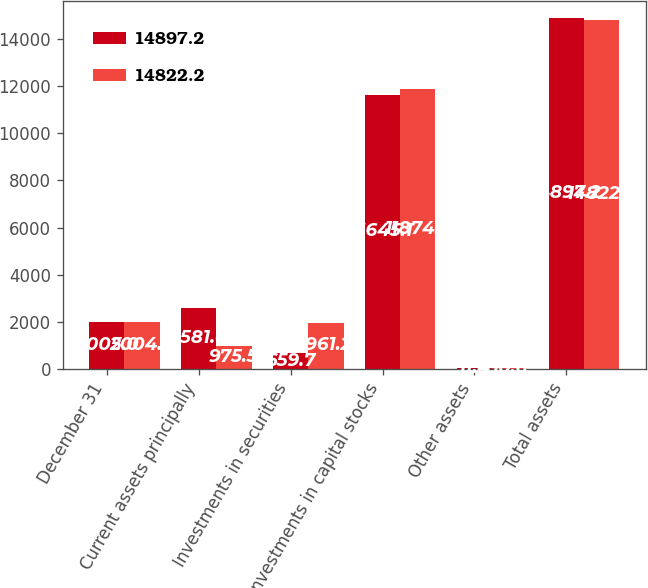Convert chart to OTSL. <chart><loc_0><loc_0><loc_500><loc_500><stacked_bar_chart><ecel><fcel>December 31<fcel>Current assets principally<fcel>Investments in securities<fcel>Investments in capital stocks<fcel>Other assets<fcel>Total assets<nl><fcel>14897.2<fcel>2005<fcel>2581<fcel>659.7<fcel>11645.1<fcel>11.4<fcel>14897.2<nl><fcel>14822.2<fcel>2004<fcel>975.5<fcel>1961.2<fcel>11874.9<fcel>10.6<fcel>14822.2<nl></chart> 